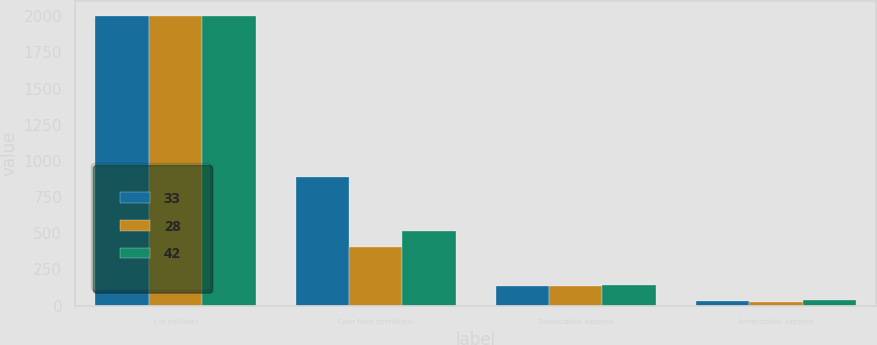Convert chart. <chart><loc_0><loc_0><loc_500><loc_500><stacked_bar_chart><ecel><fcel>( in millions)<fcel>Cash from operations<fcel>Depreciation expense<fcel>Amortization expense<nl><fcel>33<fcel>2004<fcel>891<fcel>133<fcel>33<nl><fcel>28<fcel>2003<fcel>403<fcel>132<fcel>28<nl><fcel>42<fcel>2002<fcel>516<fcel>145<fcel>42<nl></chart> 